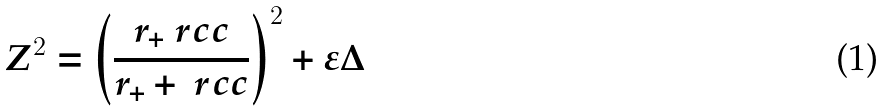Convert formula to latex. <formula><loc_0><loc_0><loc_500><loc_500>Z ^ { 2 } = \left ( \frac { r _ { + } \ r c c } { r _ { + } + \ r c c } \right ) ^ { 2 } + \varepsilon \Delta</formula> 